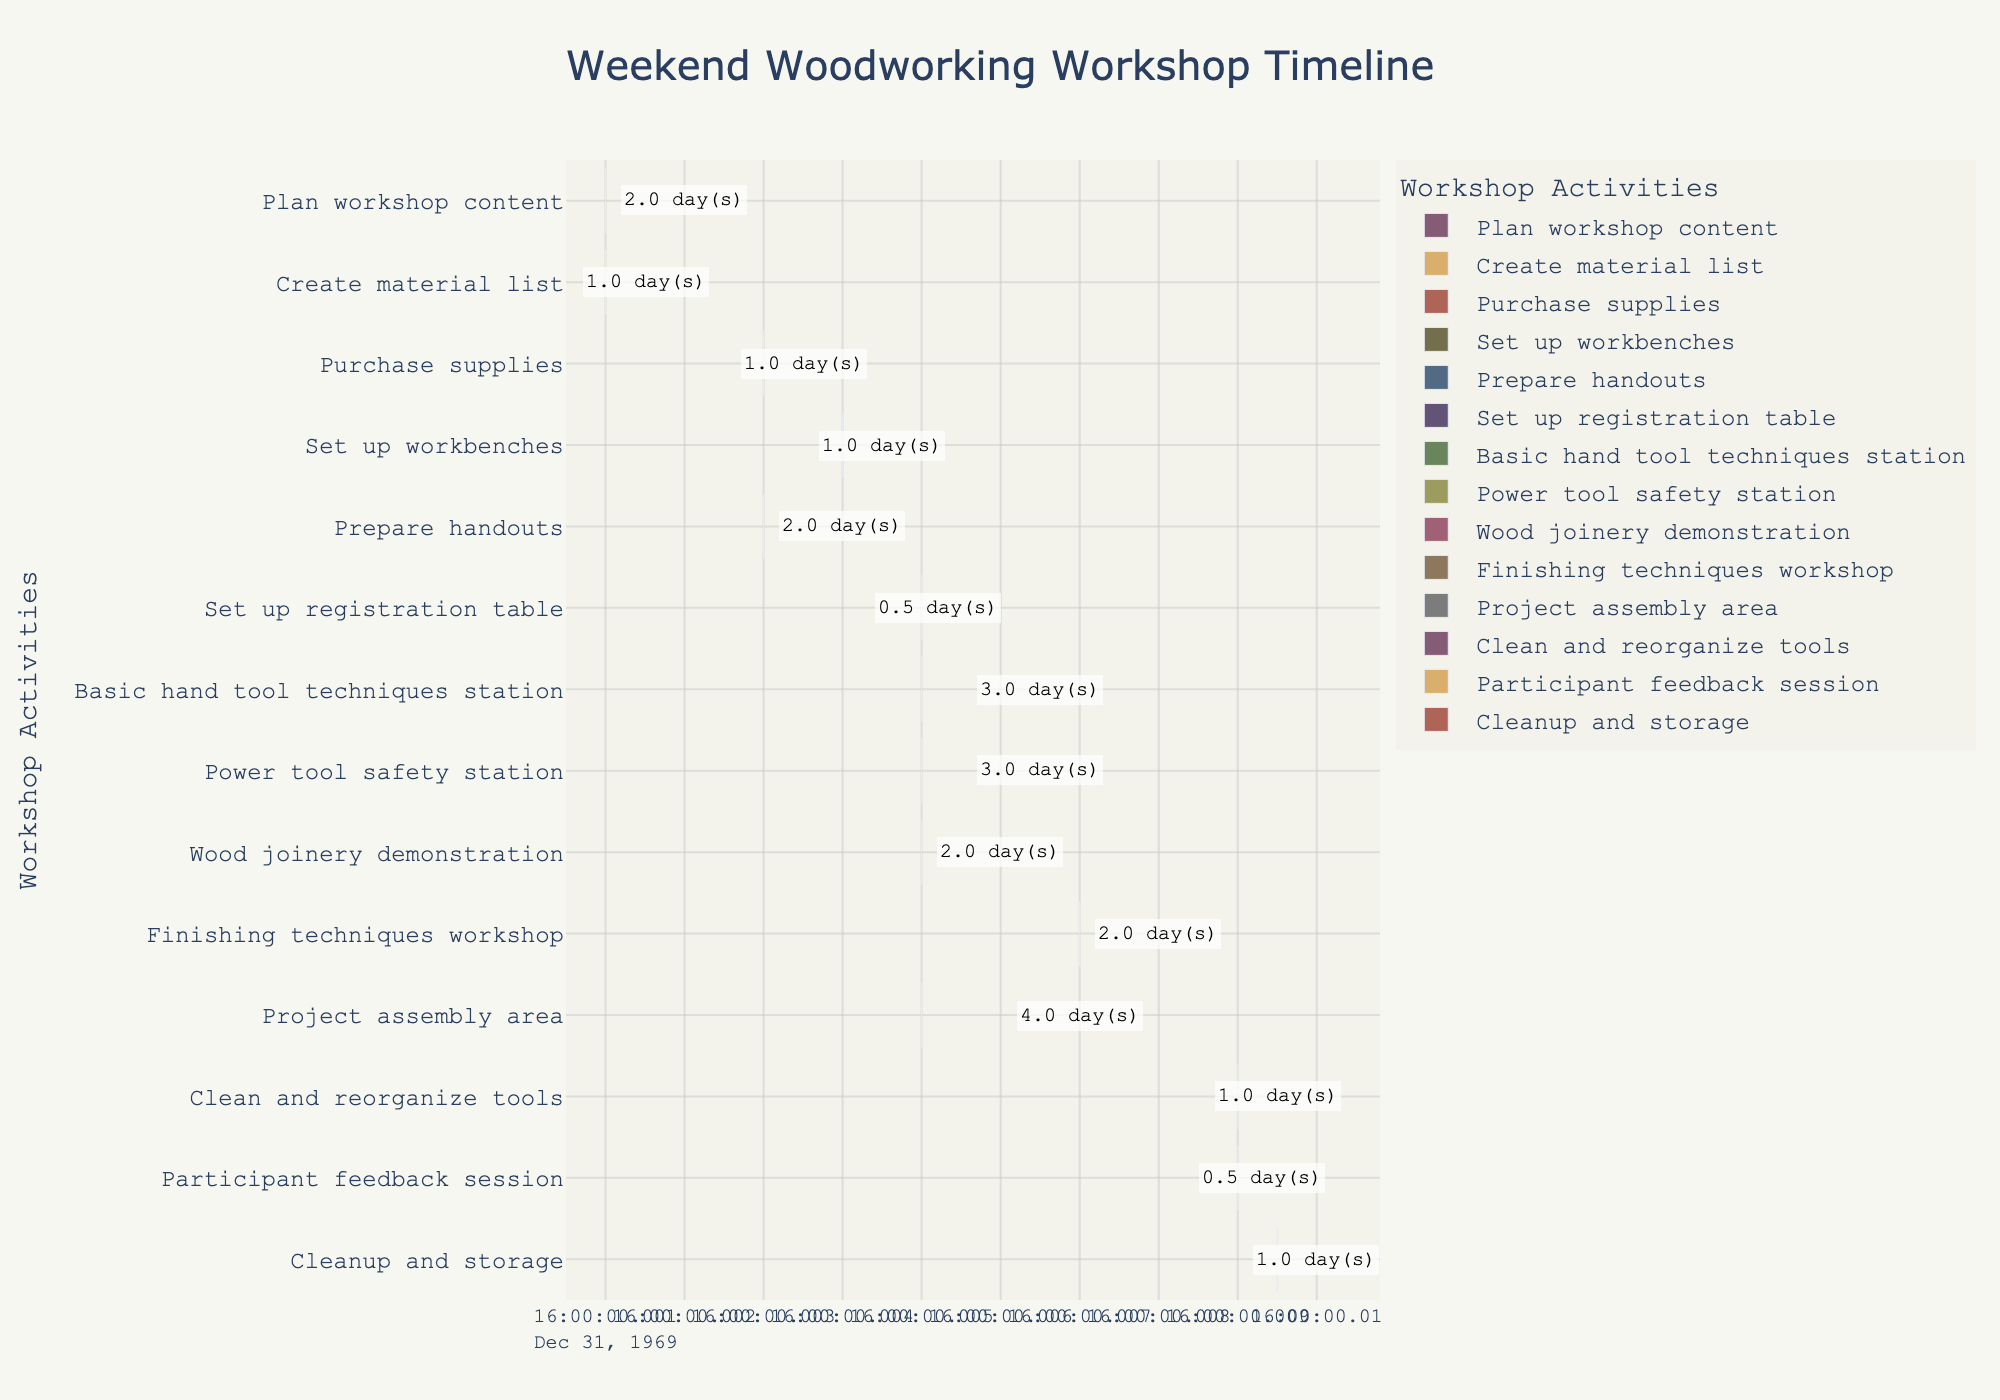What is the title of the figure? The title is located at the top of the figure and usually describes the main purpose or subject of the chart. In this case, it is clearly labeled as "Weekend Woodworking Workshop Timeline".
Answer: Weekend Woodworking Workshop Timeline Which task starts first in the timeline? The task that starts first is the one with the earliest day in the "Start" column. Here, both "Plan workshop content" and "Create material list" start on the same day, Day 1.
Answer: Plan workshop content and Create material list How many days are allocated for the "Basic hand tool techniques station"? The duration of each task is specified in the chart. For the "Basic hand tool techniques station," the duration is marked as 3 days.
Answer: 3 days Which activities are scheduled to occur on Day 5? Identify all activities whose start or end dates include Day 5. The tasks scheduled on Day 5 are: "Set up registration table," "Basic hand tool techniques station," "Power tool safety station," "Wood joinery demonstration," and "Project assembly area."
Answer: Set up registration table, Basic hand tool techniques station, Power tool safety station, Wood joinery demonstration, Project assembly area Which task has the shortest duration? The task with the shortest duration can be found by locating the smallest value in the "Duration" column. The "Set up registration table" and "Participant feedback session" both have the shortest durations at 0.5 days.
Answer: Set up registration table and Participant feedback session Compare the durations of "Plan workshop content" and "Wood joinery demonstration". Which one is longer, and by how much? The duration of "Plan workshop content" is 2 days, and the duration of "Wood joinery demonstration" is also 2 days. Since they have the same duration, neither is longer.
Answer: Same duration, 0 days difference How long does the entire workshop, including preparation and cleanup, last in terms of days? Calculate the span from the earliest start date to the latest end date. The workshop preparation starts on Day 1, and cleanup finishes on Day 10. Therefore, it spans 10 days.
Answer: 10 days What is the total duration for all cleanup-related tasks combined? Identify the duration for each cleanup-related task ("Clean and reorganize tools," "Participant feedback session," and "Cleanup and storage") and sum them up. The durations are 1, 0.5, and 1 days respectively, giving a total of 2.5 days.
Answer: 2.5 days Which task starts immediately after "Purchase supplies"? To find out which task starts immediately after another, compare the end day of "Purchase supplies" which is Day 4. The task that starts on Day 4 is "Set up workbenches".
Answer: Set up workbenches How many tasks are scheduled to last exactly 2 days? Locate all tasks with a duration of exactly 2 days. These tasks are "Plan workshop content," "Prepare handouts," "Wood joinery demonstration," and "Finishing techniques workshop." Hence, there are four tasks.
Answer: 4 tasks 